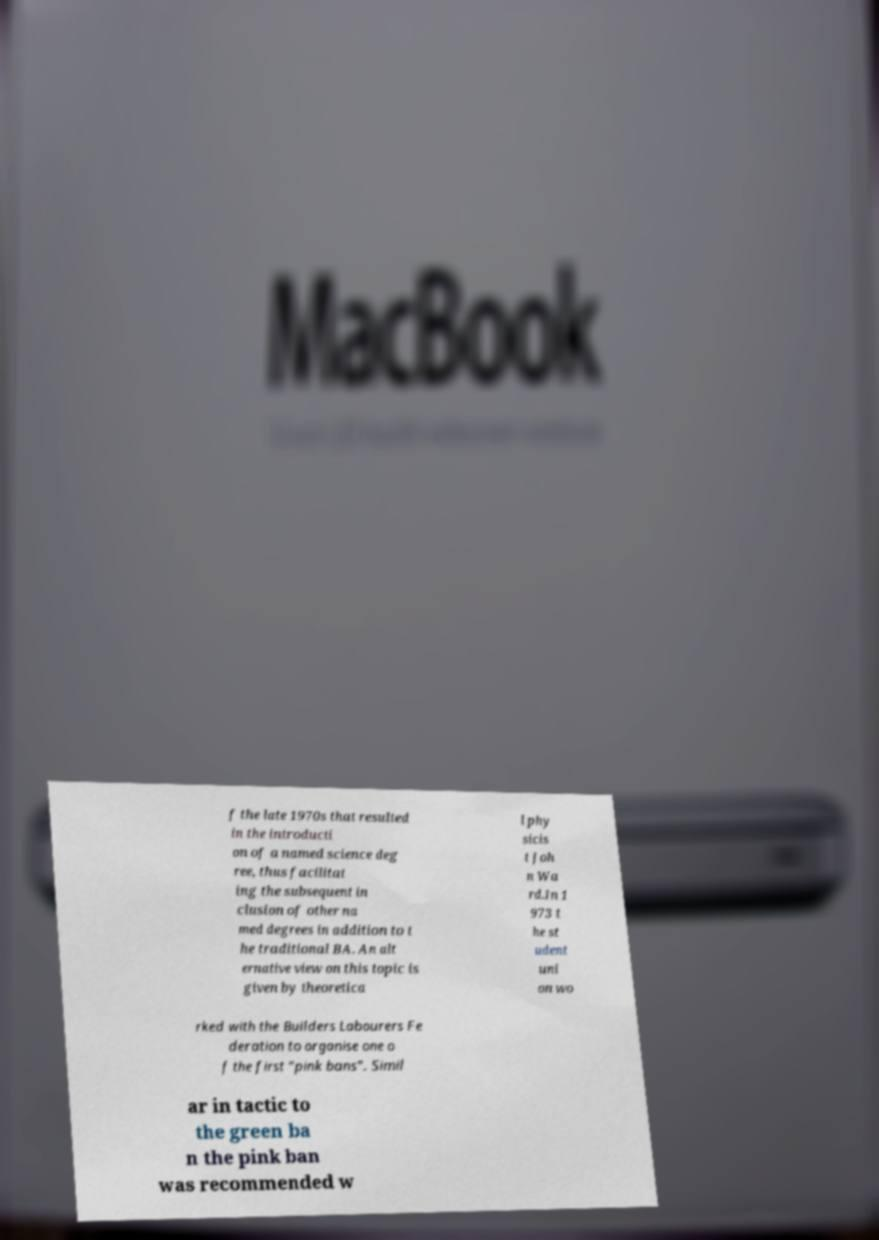Could you extract and type out the text from this image? f the late 1970s that resulted in the introducti on of a named science deg ree, thus facilitat ing the subsequent in clusion of other na med degrees in addition to t he traditional BA. An alt ernative view on this topic is given by theoretica l phy sicis t Joh n Wa rd.In 1 973 t he st udent uni on wo rked with the Builders Labourers Fe deration to organise one o f the first "pink bans". Simil ar in tactic to the green ba n the pink ban was recommended w 